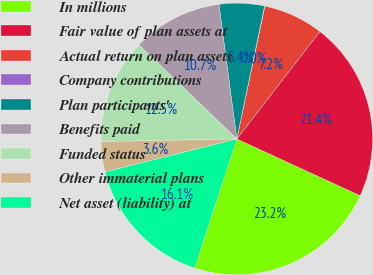<chart> <loc_0><loc_0><loc_500><loc_500><pie_chart><fcel>In millions<fcel>Fair value of plan assets at<fcel>Actual return on plan assets<fcel>Company contributions<fcel>Plan participants'<fcel>Benefits paid<fcel>Funded status<fcel>Other immaterial plans<fcel>Net asset (liability) at<nl><fcel>23.18%<fcel>21.4%<fcel>7.16%<fcel>0.04%<fcel>5.38%<fcel>10.72%<fcel>12.5%<fcel>3.6%<fcel>16.06%<nl></chart> 